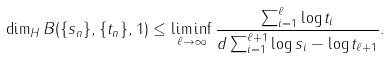<formula> <loc_0><loc_0><loc_500><loc_500>\dim _ { H } B ( \{ s _ { n } \} , \{ t _ { n } \} , 1 ) \leq \liminf _ { \ell \to \infty } \frac { \sum _ { i = 1 } ^ { \ell } \log t _ { i } } { d \sum _ { i = 1 } ^ { \ell + 1 } \log s _ { i } - \log t _ { \ell + 1 } } .</formula> 